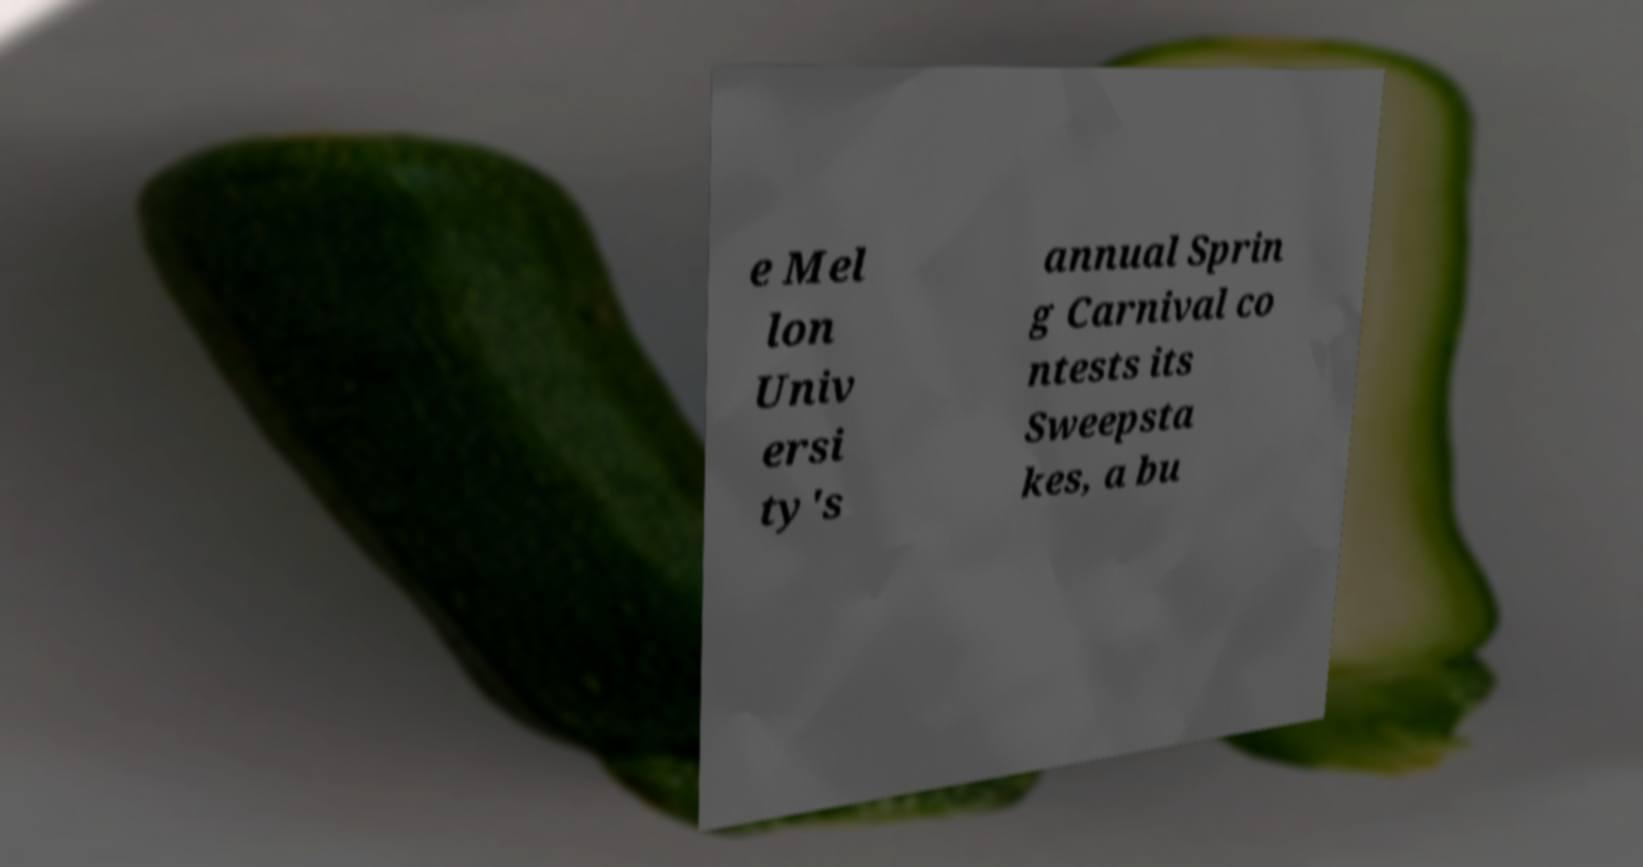Please identify and transcribe the text found in this image. e Mel lon Univ ersi ty's annual Sprin g Carnival co ntests its Sweepsta kes, a bu 